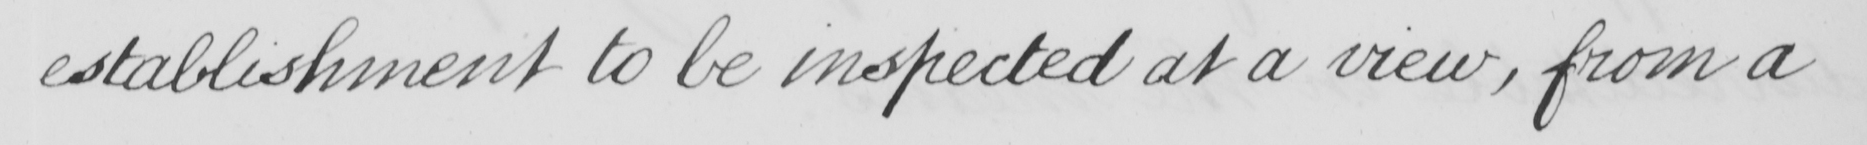Can you tell me what this handwritten text says? establishment to be inspected at a view , from a 